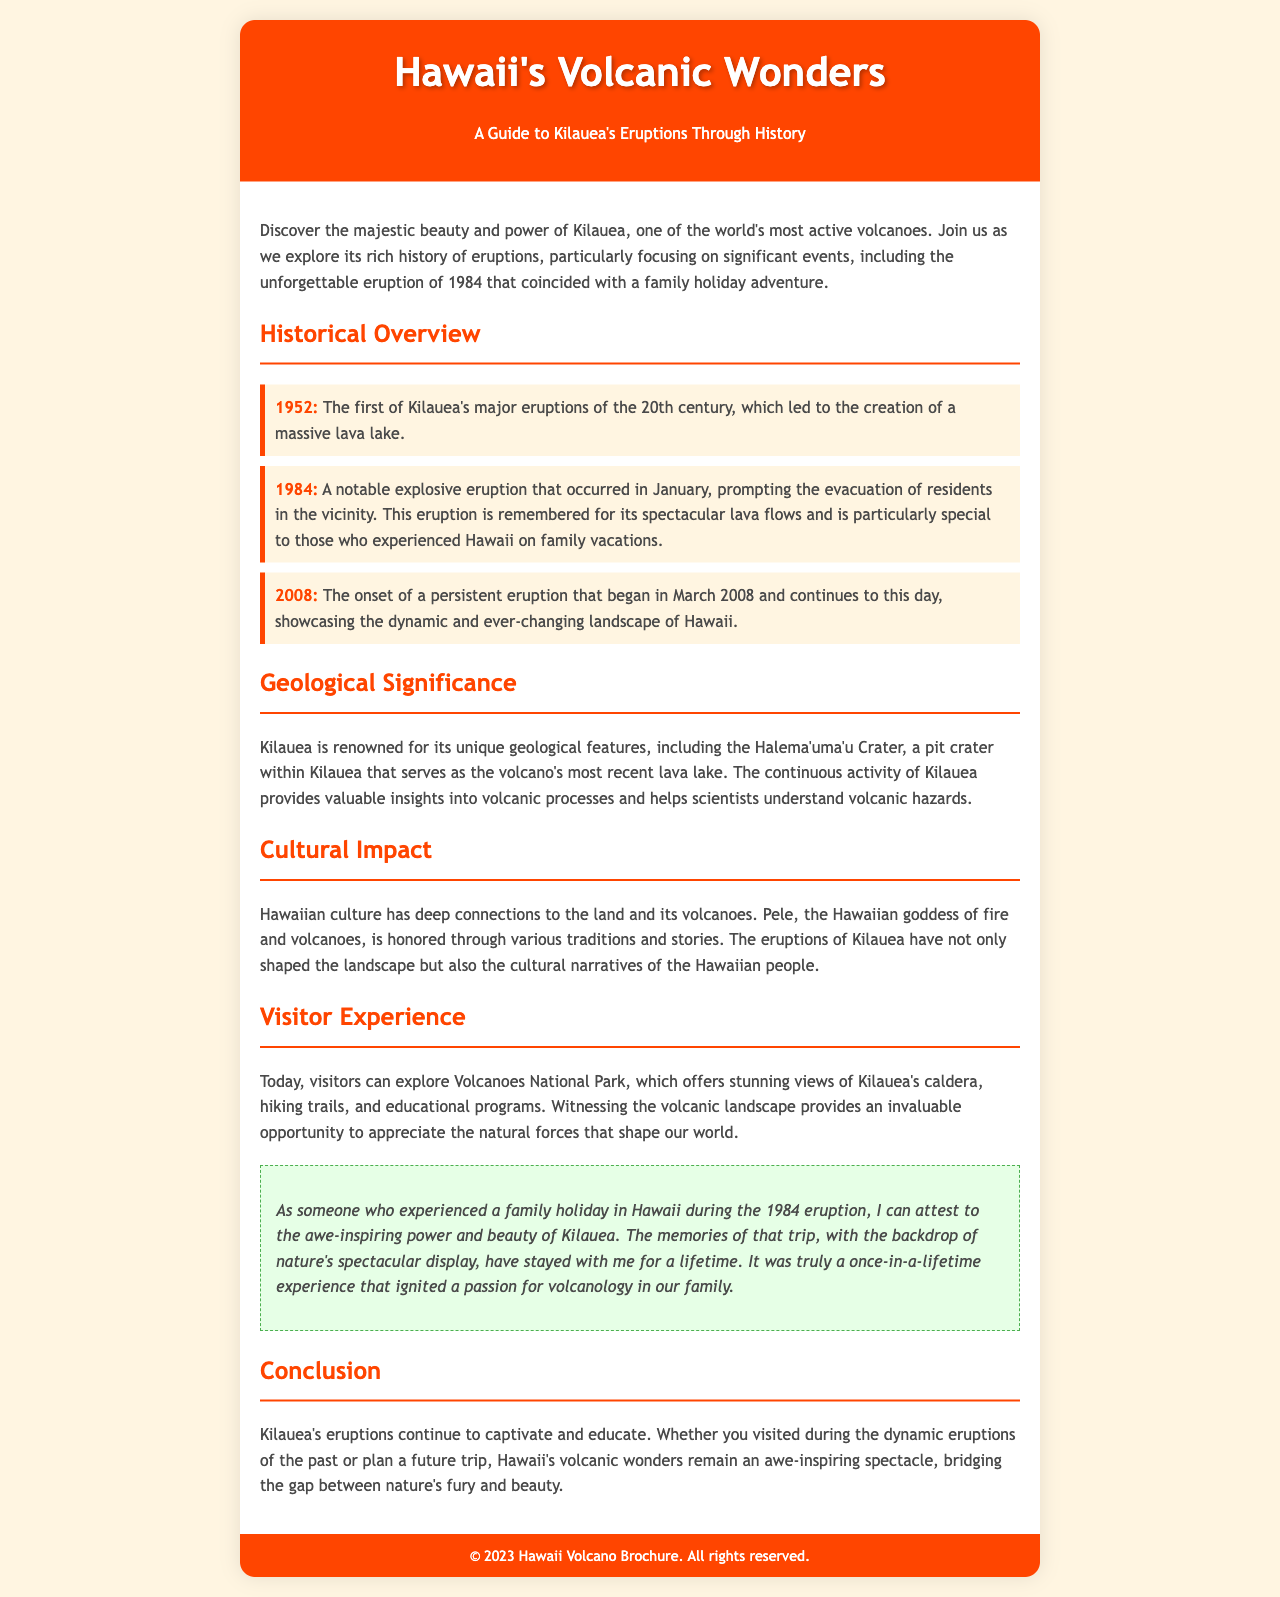What year did Kilauea's notable explosive eruption occur? The document provides specific dates of significant eruptions, including the notable explosive eruption in January 1984.
Answer: 1984 What did the 1952 eruption lead to? The document mentions that the 1952 eruption resulted in the creation of a massive lava lake, which is a significant outcome of that event.
Answer: Massive lava lake Who is honored through Hawaiian traditions and stories? The content mentions Pele as the Hawaiian goddess of fire and volcanoes, signifying her cultural importance.
Answer: Pele What is the current status of the 2008 eruption? The document states that the onset of the 2008 eruption began in March and continues to this day, highlighting its ongoing activity.
Answer: Continues to this day Which park can visitors explore to witness Kilauea? The document discusses Volcanoes National Park as the place where visitors can see Kilauea's caldera and hiking trails.
Answer: Volcanoes National Park Why is Kilauea important to scientists? The document explains that Kilauea's continuous activity provides valuable insights into volcanic processes, making it significant for scientific study.
Answer: Valuable insights What emotional impact did the 1984 eruption have on families visiting Hawaii? The personal note in the document reflects on the awe-inspiring power and beauty of Kilauea during family holidays, indicating a lasting emotional impression.
Answer: Awe-inspiring power and beauty What is the color theme of the brochure? The document describes a warm color palette with an orange background for the header and various shades throughout, helping to create a thematic design.
Answer: Warm color palette 